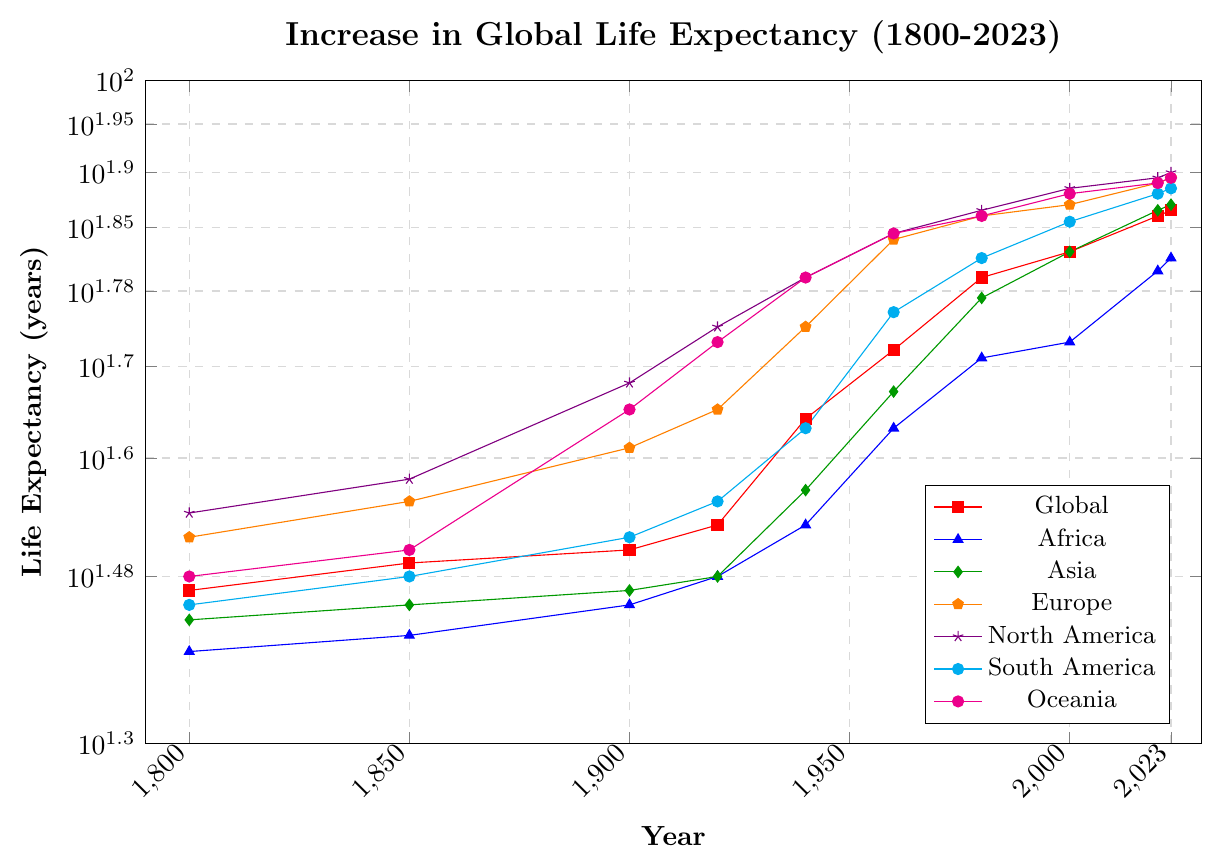How much did life expectancy in Europe increase from 1800 to 2023? From the figure, life expectancy in Europe increased from 33 years in 1800 to 79 years in 2023. The increase is calculated as 79 - 33.
Answer: 46 years Which region had the smallest increase in life expectancy from 1800 to 2023? From the figure, by visually estimating the change for each region, Africa had the smallest increase from 25 to 65 years. This is an increase of 40 years.
Answer: Africa Which region had the highest life expectancy in 1900? From the plot, North America's life expectancy in 1900 is 48 years, which is the highest compared to other regions.
Answer: North America How does the life expectancy in Oceania in 2023 compare to that in Asia in 2023? In 2023, the life expectancy in Oceania is 79 years, while in Asia it is 74 years. Comparing these values, Oceania's life expectancy is higher.
Answer: Oceania has a higher life expectancy What is the average life expectancy across all regions in 1920? To find the average for 1920: (Global 34 + Africa 30 + Asia 30 + Europe 45 + North America 55 + South America 36 + Oceania 53)/7 ≈ 40.43.
Answer: 40.43 years Which region had the largest increase in life expectancy between 1940 and 1960? Comparing the increase from 1940 to 1960 for each region, Africa went from 34 to 43, Asia from 37 to 47, Europe from 55 to 68, North America from 62 to 69, South America from 43 to 57, and Oceania from 62 to 69. The largest increase was in South America, which increased by 14 years (57-43).
Answer: South America By how many years did the global life expectancy increase every decade between 1800 and 2023, on average? First, calculate the total increase from 1800 to 2023: 73 - 29 = 44 years. There are 223 years between 1800 and 2023, which equals 22.3 decades. The average increase per decade is calculated as 44 / 22.3 ≈ 1.97 years.
Answer: 1.97 years per decade Which region's life expectancy growth rate leveled off the most after 1960? By visually inspecting the graph, after 1960, North America's life expectancy shows the least steep increase indicating a more leveled-off growth compared to others.
Answer: North America What was the difference in life expectancy between South America and Africa in 2000? In 2000, South America's life expectancy was 71 years and Africa's was 53 years. The difference is calculated as 71 - 53.
Answer: 18 years Identify the region that consistently had the lowest life expectancy from 1800 to 2023. Upon reviewing the figure, Africa consistently shows the lowest life expectancy throughout the displayed time period.
Answer: Africa 